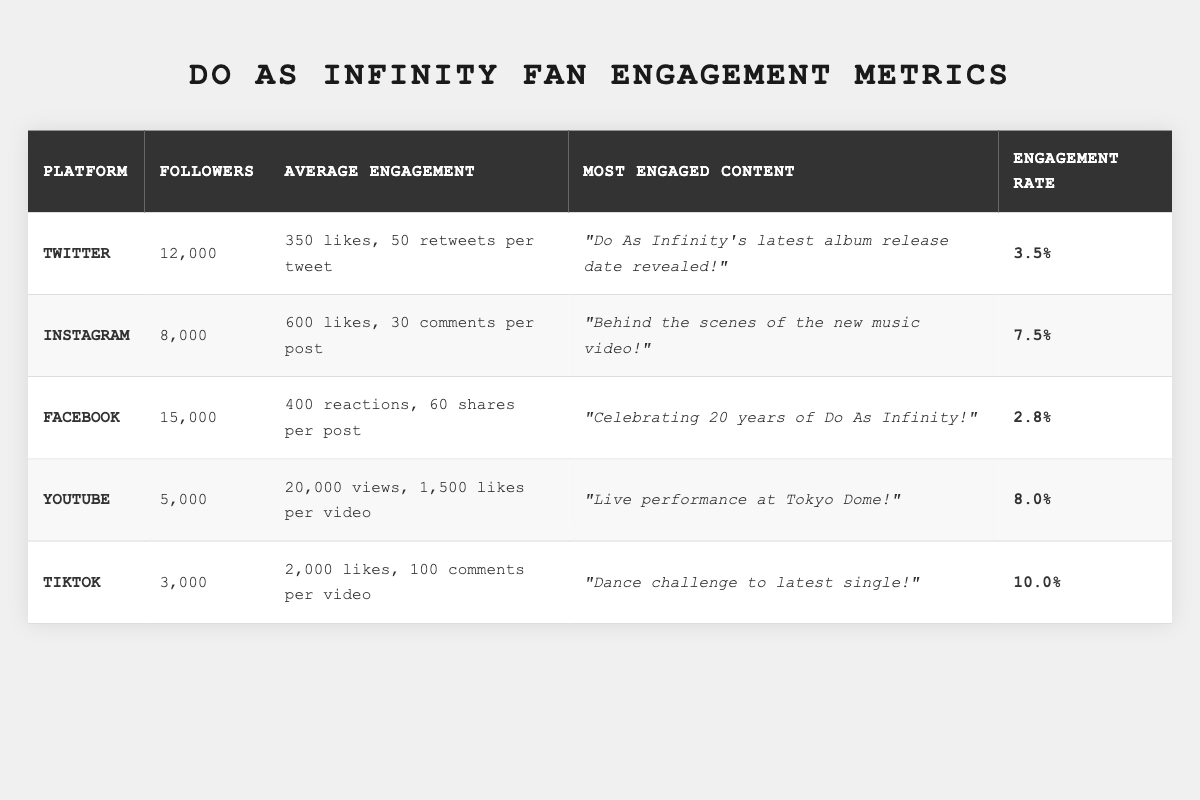What is the total number of followers across all platforms? To find the total number of followers, I will sum the followers from each platform: Twitter (12,000) + Instagram (8,000) + Facebook (15,000) + YouTube (5,000) + TikTok (3,000) = 43,000.
Answer: 43,000 Which platform has the highest engagement rate? The engagement rates for each platform are: Twitter (3.5%), Instagram (7.5%), Facebook (2.8%), YouTube (8.0%), and TikTok (10.0%). Among these, TikTok has the highest engagement rate at 10.0%.
Answer: TikTok How many average likes are received per video on YouTube? The table states that on YouTube, there are an average of 1,500 likes per video.
Answer: 1,500 Which content type received the most engagement on Instagram? The most engaged post on Instagram is "Behind the scenes of the new music video!" according to the data provided in the table.
Answer: "Behind the scenes of the new music video!" What is the total average engagement (likes and comments) on Instagram? On Instagram, the average likes per post is 600, and the average comments per post is 30. Therefore, the total average engagement is 600 + 30 = 630.
Answer: 630 Is the engagement rate on Facebook higher than that on Twitter? The engagement rates are 2.8% for Facebook and 3.5% for Twitter. Since 2.8% is lower than 3.5%, the engagement rate on Facebook is not higher than that on Twitter.
Answer: No What is the difference in the number of followers between the platform with the most and the least followers? The platform with the most followers is Facebook with 15,000, and the platform with the least followers is TikTok with 3,000. The difference is 15,000 - 3,000 = 12,000.
Answer: 12,000 How many total reactions and shares does Facebook receive on average per post? On Facebook, the average reactions per post is 400, and the average shares per post is 60. The total average reactions and shares is 400 + 60 = 460.
Answer: 460 Which platform has the most engaged content in terms of the number of likes? Looking at the averages provided, TikTok has the most average likes per video at 2,000, compared to other platforms.
Answer: TikTok What is the average engagement rate across all platforms? The engagement rates are: Twitter (3.5%), Instagram (7.5%), Facebook (2.8%), YouTube (8.0%), and TikTok (10.0%). To find the average, sum them up: (3.5 + 7.5 + 2.8 + 8.0 + 10.0) / 5 = 6.36%.
Answer: 6.36% 